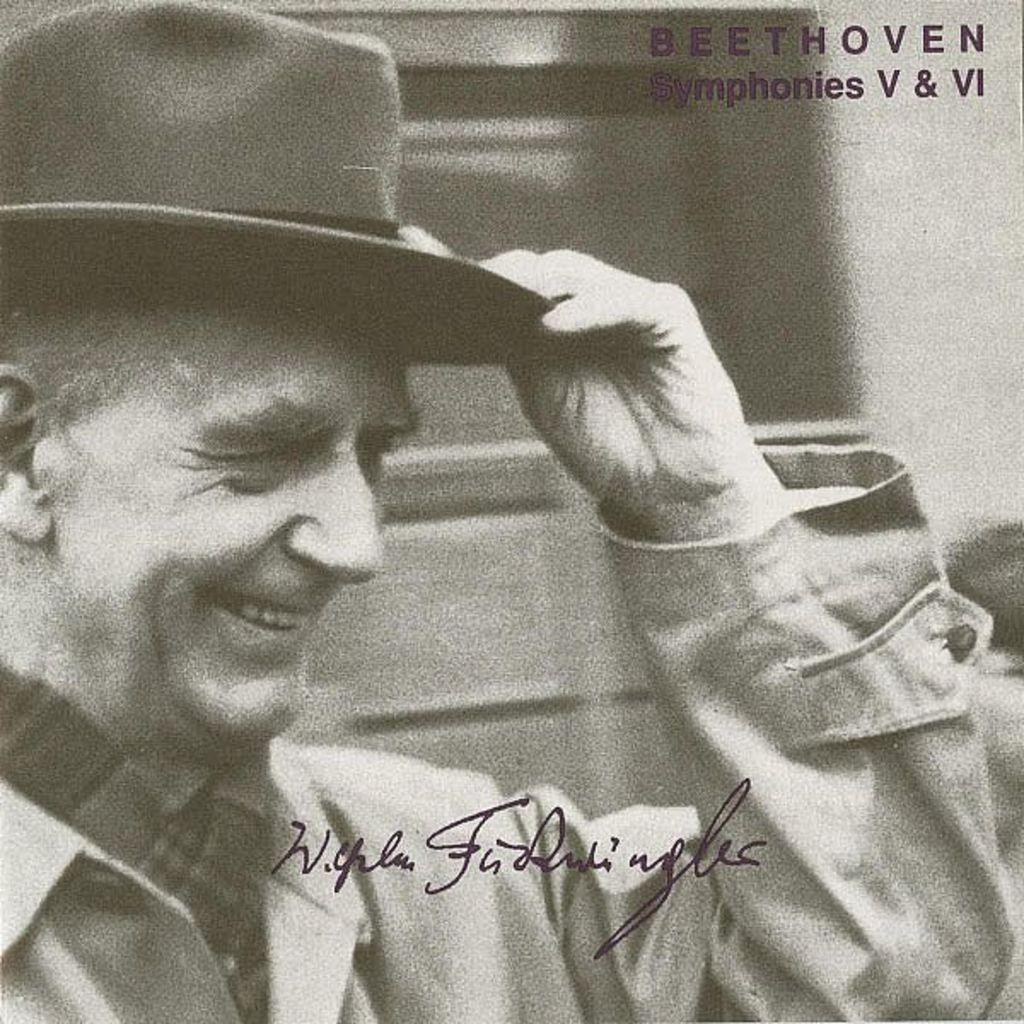What is the color scheme of the image? The image is black and white. Who is present in the image? There is a man in the image. What is the man wearing on his head? The man is wearing a hat. What can be seen behind the man in the image? There are blurred items behind the man. What is present on the image that might indicate its origin or ownership? There is a watermark on the image. Can you tell me how many balls are visible in the image? There are no balls present in the image. What type of stretch is the man performing in the image? The man is not performing any stretch in the image; he is simply standing there with a hat on. 